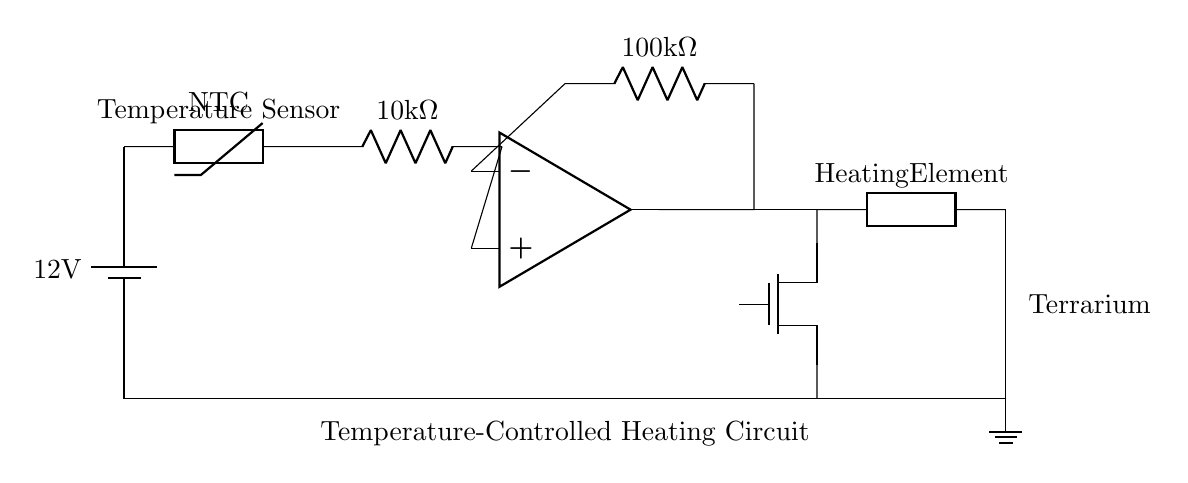What is the voltage of this circuit? The voltage is 12 volts, as indicated by the battery label in the circuit.
Answer: 12 volts What type of temperature sensor is used? The circuit diagram specifies an NTC thermistor, which is a type of temperature sensor that decreases resistance as temperature increases.
Answer: NTC thermistor What is the resistance value of the resistor connected to the thermistor? The resistor connected to the thermistor is labeled as having a value of 10 kilo-ohms, which is the resistance measured in thousands of ohms.
Answer: 10 kilo-ohms How does the operational amplifier function in this circuit? The operational amplifier amplifies the voltage difference between the thermistor and the reference voltage provided by the resistor, allowing for control of the MOSFET based on temperature changes.
Answer: Amplifies voltage difference What component acts as the heating element? The heating element in this circuit is represented as a generic component labeled "Heating Element," which generates heat to maintain the desired temperature in the terrarium.
Answer: Heating Element What configuration does the MOSFET have in this circuit? The MOSFET is connected in a totem-pole configuration, where it acts as a switch to control the power to the heating element based on the output from the operational amplifier.
Answer: Totem-pole configuration What purpose does the 100k resistor serve in this circuit? The 100 kilo-ohm resistor serves as feedback to the operational amplifier, which stabilizes the circuit and sets the gain, impacting how much the output voltage responds to the temperature sensed by the thermistor.
Answer: Feedback resistor 